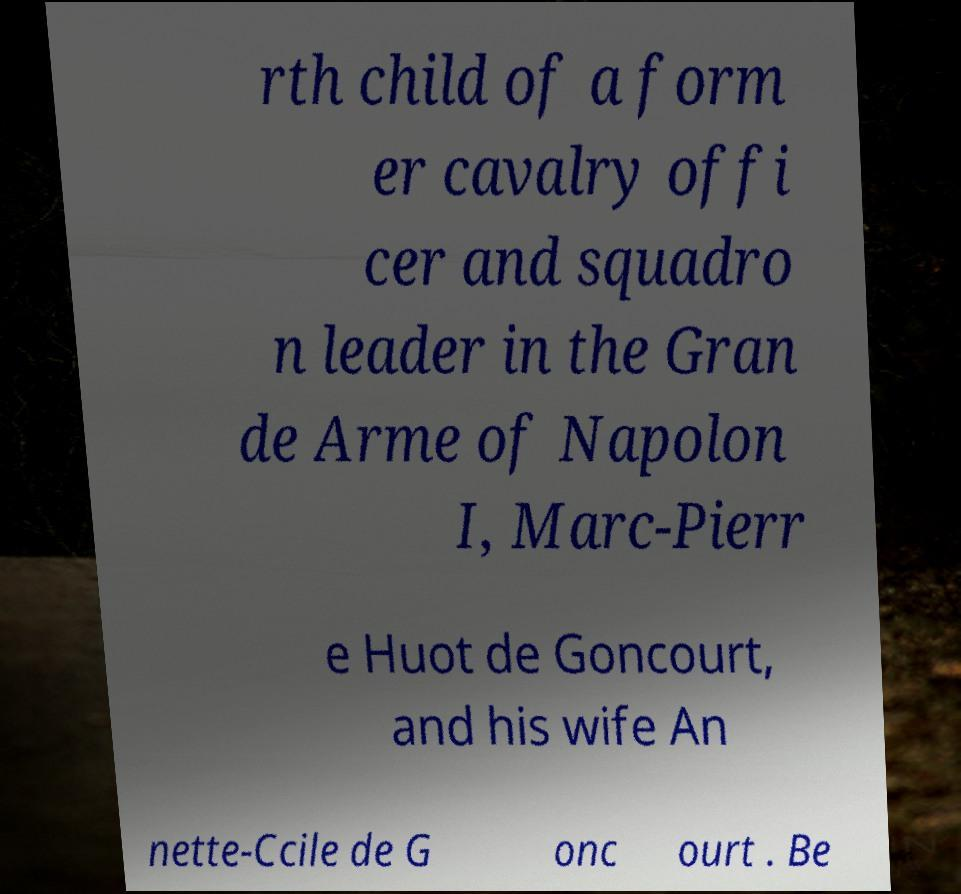Could you assist in decoding the text presented in this image and type it out clearly? rth child of a form er cavalry offi cer and squadro n leader in the Gran de Arme of Napolon I, Marc-Pierr e Huot de Goncourt, and his wife An nette-Ccile de G onc ourt . Be 